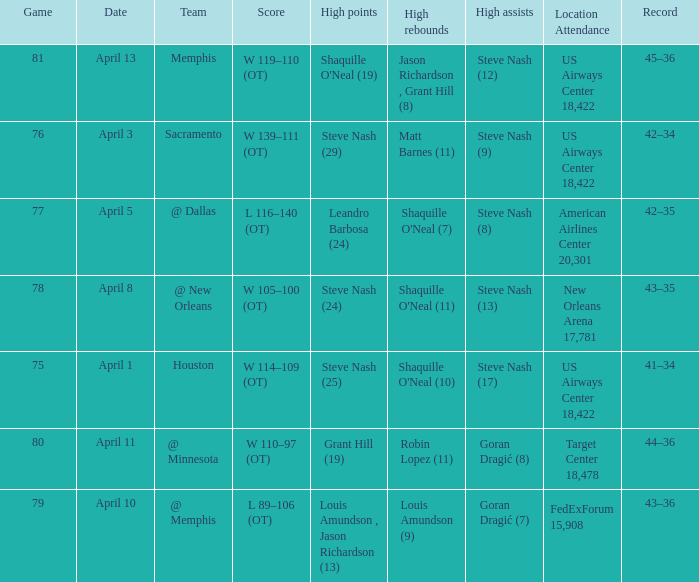Who did the most assists when Matt Barnes (11) got the most rebounds? Steve Nash (9). 